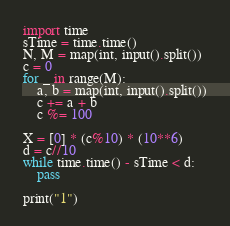<code> <loc_0><loc_0><loc_500><loc_500><_Python_>import time
sTime = time.time()
N, M = map(int, input().split())
c = 0
for _ in range(M):
    a, b = map(int, input().split())
    c += a + b
    c %= 100

X = [0] * (c%10) * (10**6)
d = c//10
while time.time() - sTime < d:
    pass

print("1")</code> 